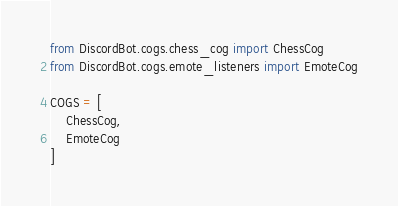Convert code to text. <code><loc_0><loc_0><loc_500><loc_500><_Python_>from DiscordBot.cogs.chess_cog import ChessCog
from DiscordBot.cogs.emote_listeners import EmoteCog

COGS = [
    ChessCog,
    EmoteCog
]
</code> 